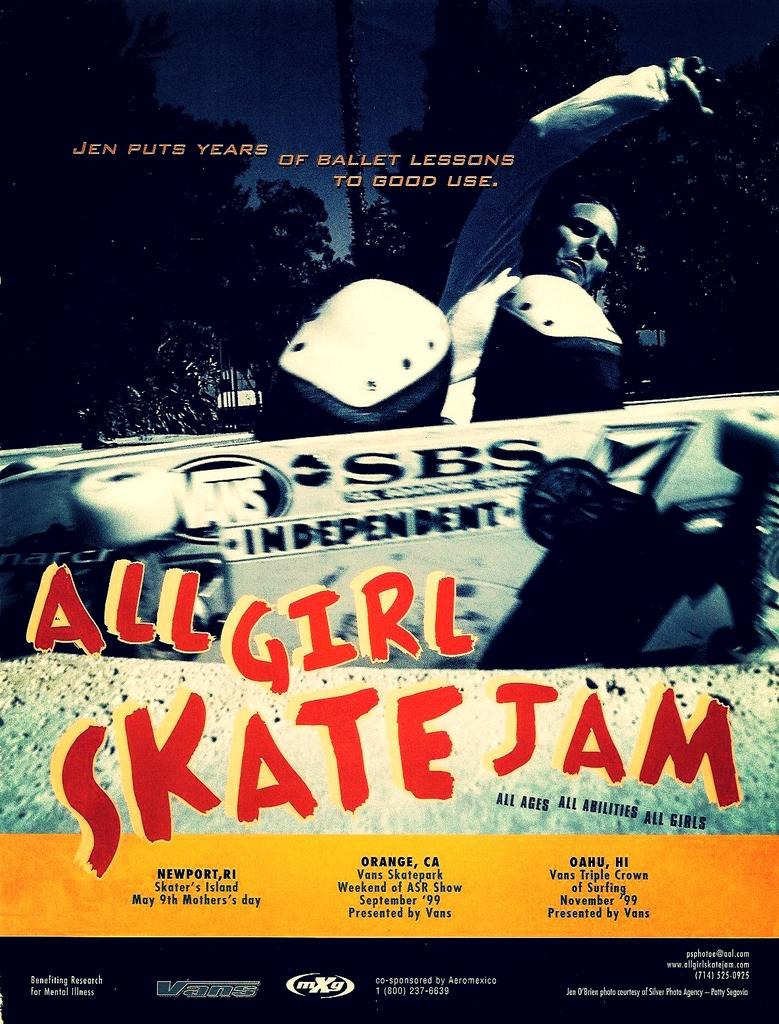Provide a one-sentence caption for the provided image. A poster for All Girl Skate Jam where Jen is showing how she puts ballet lessons to work. 